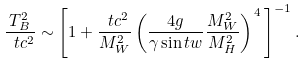<formula> <loc_0><loc_0><loc_500><loc_500>\frac { T _ { B } ^ { 2 } } { \ t c ^ { 2 } } \sim \left [ 1 + \frac { \ t c ^ { 2 } } { M _ { W } ^ { 2 } } \left ( \frac { 4 g } { \gamma \sin t w } \frac { M _ { W } ^ { 2 } } { M _ { H } ^ { 2 } } \right ) ^ { \, 4 } \, \right ] ^ { - 1 } .</formula> 